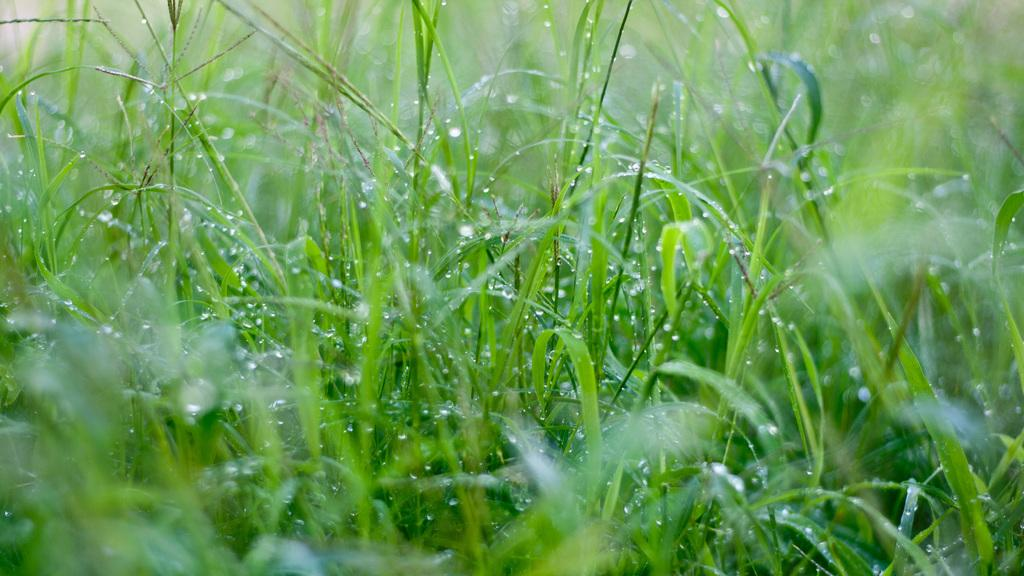What type of vegetation is present in the image? There is grass in the image. Can you describe the condition of the grass? The grass has water droplets on it. What type of nail can be seen in the image? There is no nail present in the image; it only features grass with water droplets. 